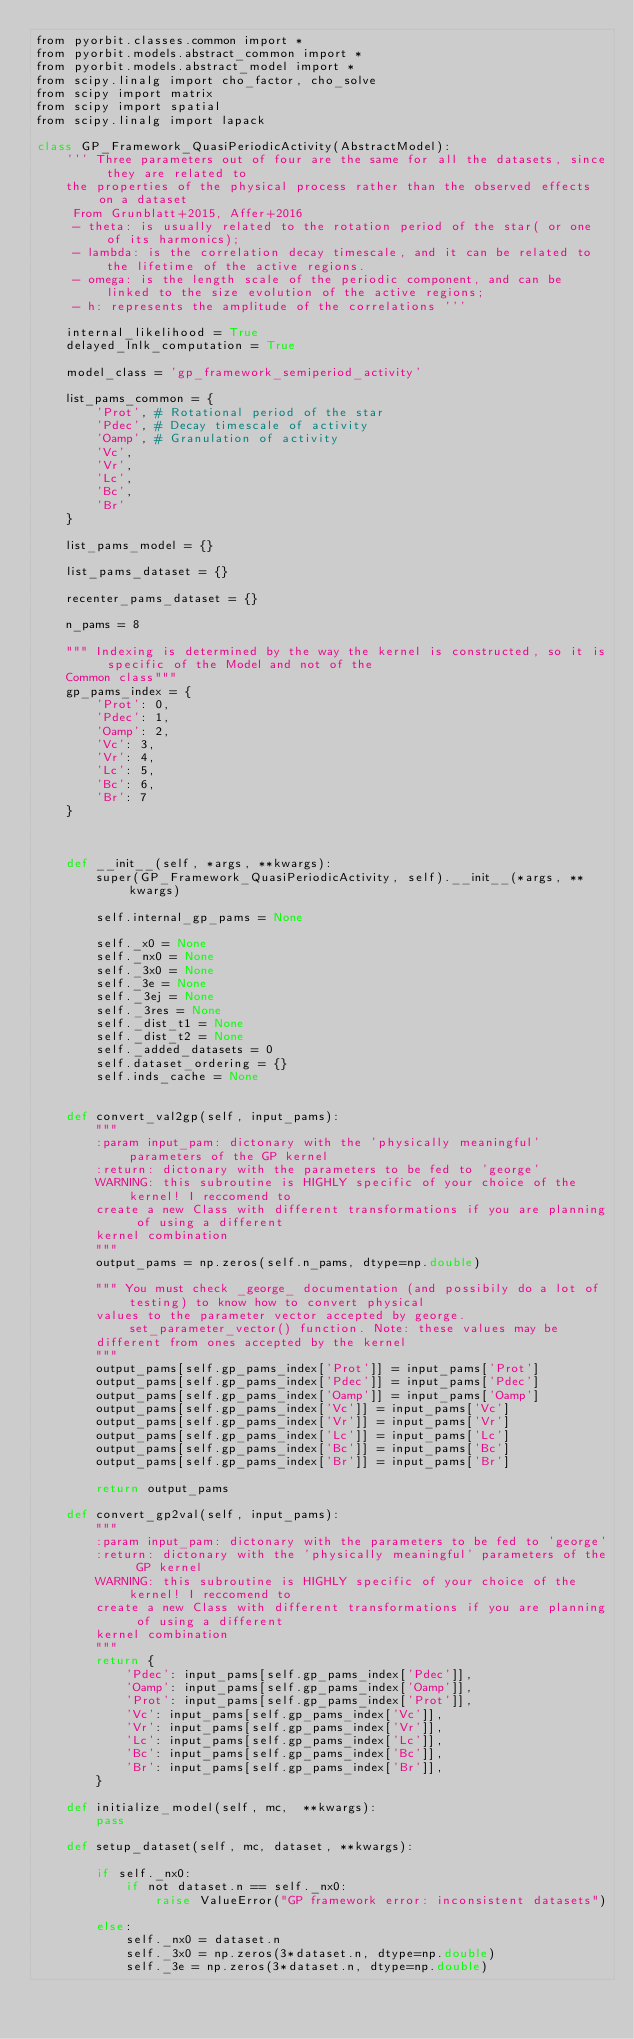<code> <loc_0><loc_0><loc_500><loc_500><_Cython_>from pyorbit.classes.common import *
from pyorbit.models.abstract_common import *
from pyorbit.models.abstract_model import *
from scipy.linalg import cho_factor, cho_solve
from scipy import matrix
from scipy import spatial
from scipy.linalg import lapack

class GP_Framework_QuasiPeriodicActivity(AbstractModel):
    ''' Three parameters out of four are the same for all the datasets, since they are related to
    the properties of the physical process rather than the observed effects on a dataset
     From Grunblatt+2015, Affer+2016
     - theta: is usually related to the rotation period of the star( or one of its harmonics);
     - lambda: is the correlation decay timescale, and it can be related to the lifetime of the active regions.
     - omega: is the length scale of the periodic component, and can be linked to the size evolution of the active regions;
     - h: represents the amplitude of the correlations '''

    internal_likelihood = True
    delayed_lnlk_computation = True

    model_class = 'gp_framework_semiperiod_activity'

    list_pams_common = {
        'Prot', # Rotational period of the star
        'Pdec', # Decay timescale of activity
        'Oamp', # Granulation of activity
        'Vc',
        'Vr',
        'Lc',
        'Bc',
        'Br'
    }

    list_pams_model = {}

    list_pams_dataset = {}

    recenter_pams_dataset = {}

    n_pams = 8

    """ Indexing is determined by the way the kernel is constructed, so it is specific of the Model and not of the 
    Common class"""
    gp_pams_index = {
        'Prot': 0,
        'Pdec': 1,
        'Oamp': 2,
        'Vc': 3,
        'Vr': 4,
        'Lc': 5,
        'Bc': 6,
        'Br': 7
    }



    def __init__(self, *args, **kwargs):
        super(GP_Framework_QuasiPeriodicActivity, self).__init__(*args, **kwargs)

        self.internal_gp_pams = None

        self._x0 = None
        self._nx0 = None
        self._3x0 = None
        self._3e = None
        self._3ej = None
        self._3res = None
        self._dist_t1 = None
        self._dist_t2 = None
        self._added_datasets = 0
        self.dataset_ordering = {}
        self.inds_cache = None


    def convert_val2gp(self, input_pams):
        """
        :param input_pam: dictonary with the 'physically meaningful' parameters of the GP kernel
        :return: dictonary with the parameters to be fed to 'george'
        WARNING: this subroutine is HIGHLY specific of your choice of the kernel! I reccomend to
        create a new Class with different transformations if you are planning of using a different
        kernel combination
        """
        output_pams = np.zeros(self.n_pams, dtype=np.double)

        """ You must check _george_ documentation (and possibily do a lot of testing) to know how to convert physical 
        values to the parameter vector accepted by george.set_parameter_vector() function. Note: these values may be 
        different from ones accepted by the kernel
        """
        output_pams[self.gp_pams_index['Prot']] = input_pams['Prot']
        output_pams[self.gp_pams_index['Pdec']] = input_pams['Pdec']
        output_pams[self.gp_pams_index['Oamp']] = input_pams['Oamp']
        output_pams[self.gp_pams_index['Vc']] = input_pams['Vc']
        output_pams[self.gp_pams_index['Vr']] = input_pams['Vr']
        output_pams[self.gp_pams_index['Lc']] = input_pams['Lc']
        output_pams[self.gp_pams_index['Bc']] = input_pams['Bc']
        output_pams[self.gp_pams_index['Br']] = input_pams['Br']

        return output_pams

    def convert_gp2val(self, input_pams):
        """
        :param input_pam: dictonary with the parameters to be fed to 'george'
        :return: dictonary with the 'physically meaningful' parameters of the GP kernel
        WARNING: this subroutine is HIGHLY specific of your choice of the kernel! I reccomend to
        create a new Class with different transformations if you are planning of using a different
        kernel combination
        """
        return {
            'Pdec': input_pams[self.gp_pams_index['Pdec']],
            'Oamp': input_pams[self.gp_pams_index['Oamp']],
            'Prot': input_pams[self.gp_pams_index['Prot']],
            'Vc': input_pams[self.gp_pams_index['Vc']],
            'Vr': input_pams[self.gp_pams_index['Vr']],
            'Lc': input_pams[self.gp_pams_index['Lc']],
            'Bc': input_pams[self.gp_pams_index['Bc']],
            'Br': input_pams[self.gp_pams_index['Br']],
        }

    def initialize_model(self, mc,  **kwargs):
        pass

    def setup_dataset(self, mc, dataset, **kwargs):

        if self._nx0:
            if not dataset.n == self._nx0:
                raise ValueError("GP framework error: inconsistent datasets")

        else:
            self._nx0 = dataset.n
            self._3x0 = np.zeros(3*dataset.n, dtype=np.double)
            self._3e = np.zeros(3*dataset.n, dtype=np.double)</code> 